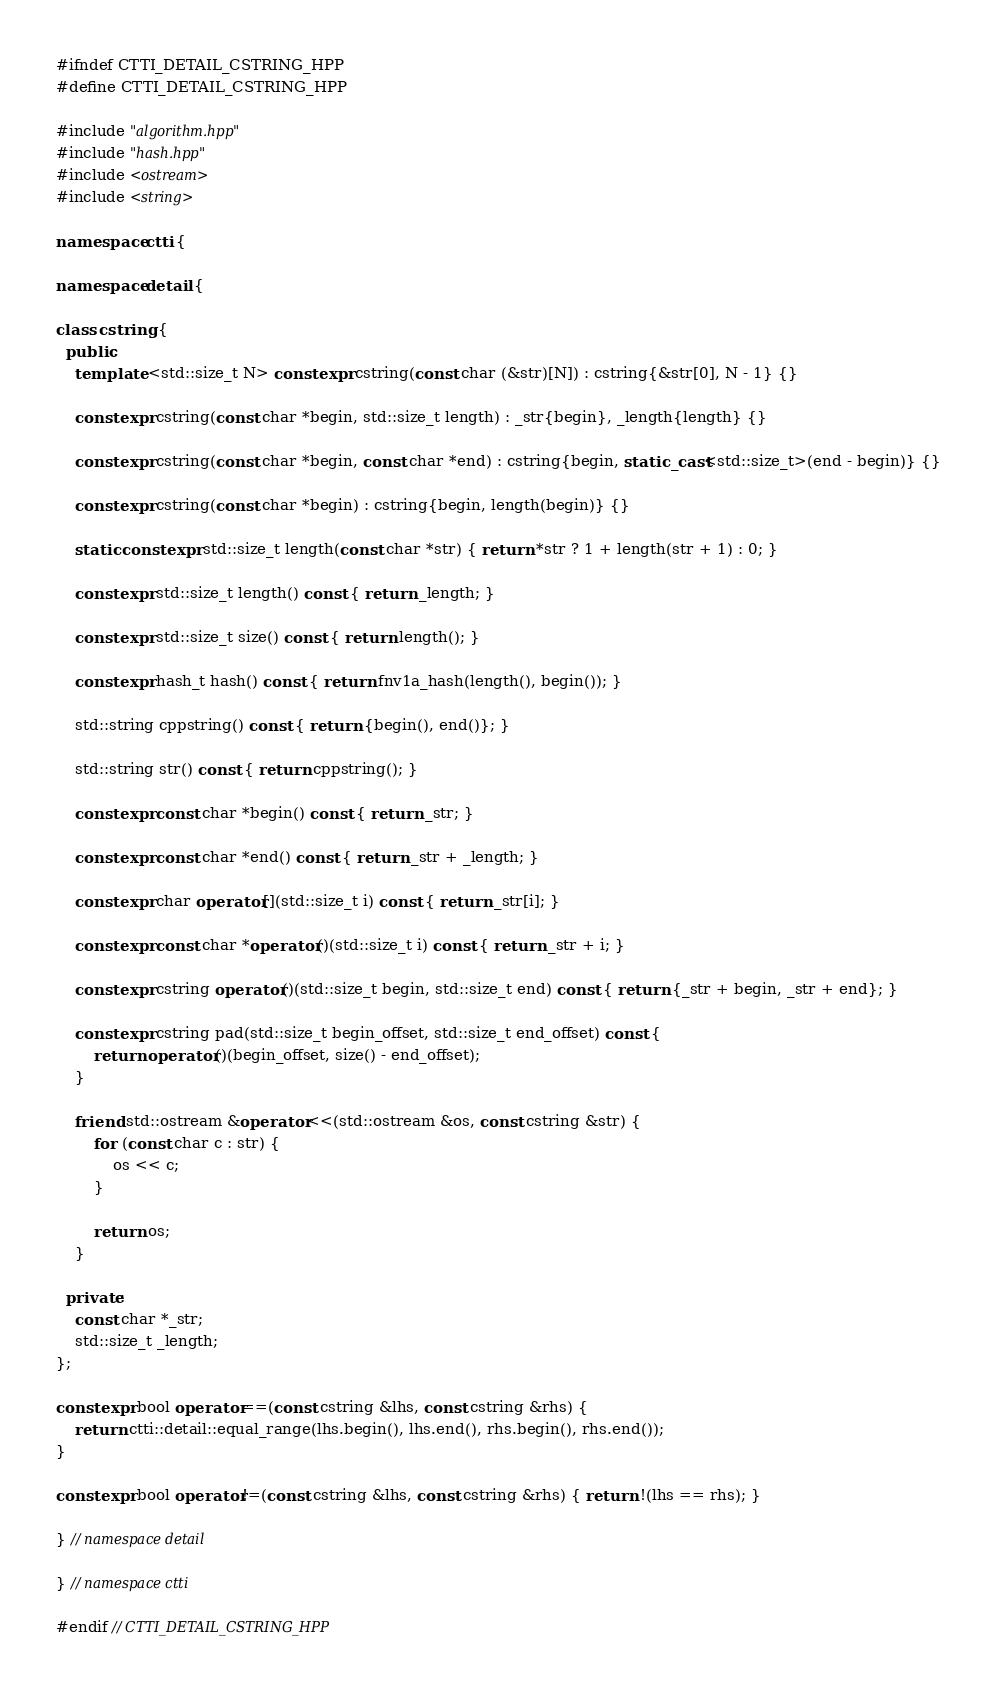<code> <loc_0><loc_0><loc_500><loc_500><_C++_>#ifndef CTTI_DETAIL_CSTRING_HPP
#define CTTI_DETAIL_CSTRING_HPP

#include "algorithm.hpp"
#include "hash.hpp"
#include <ostream>
#include <string>

namespace ctti {

namespace detail {

class cstring {
  public:
    template <std::size_t N> constexpr cstring(const char (&str)[N]) : cstring{&str[0], N - 1} {}

    constexpr cstring(const char *begin, std::size_t length) : _str{begin}, _length{length} {}

    constexpr cstring(const char *begin, const char *end) : cstring{begin, static_cast<std::size_t>(end - begin)} {}

    constexpr cstring(const char *begin) : cstring{begin, length(begin)} {}

    static constexpr std::size_t length(const char *str) { return *str ? 1 + length(str + 1) : 0; }

    constexpr std::size_t length() const { return _length; }

    constexpr std::size_t size() const { return length(); }

    constexpr hash_t hash() const { return fnv1a_hash(length(), begin()); }

    std::string cppstring() const { return {begin(), end()}; }

    std::string str() const { return cppstring(); }

    constexpr const char *begin() const { return _str; }

    constexpr const char *end() const { return _str + _length; }

    constexpr char operator[](std::size_t i) const { return _str[i]; }

    constexpr const char *operator()(std::size_t i) const { return _str + i; }

    constexpr cstring operator()(std::size_t begin, std::size_t end) const { return {_str + begin, _str + end}; }

    constexpr cstring pad(std::size_t begin_offset, std::size_t end_offset) const {
        return operator()(begin_offset, size() - end_offset);
    }

    friend std::ostream &operator<<(std::ostream &os, const cstring &str) {
        for (const char c : str) {
            os << c;
        }

        return os;
    }

  private:
    const char *_str;
    std::size_t _length;
};

constexpr bool operator==(const cstring &lhs, const cstring &rhs) {
    return ctti::detail::equal_range(lhs.begin(), lhs.end(), rhs.begin(), rhs.end());
}

constexpr bool operator!=(const cstring &lhs, const cstring &rhs) { return !(lhs == rhs); }

} // namespace detail

} // namespace ctti

#endif // CTTI_DETAIL_CSTRING_HPP
</code> 